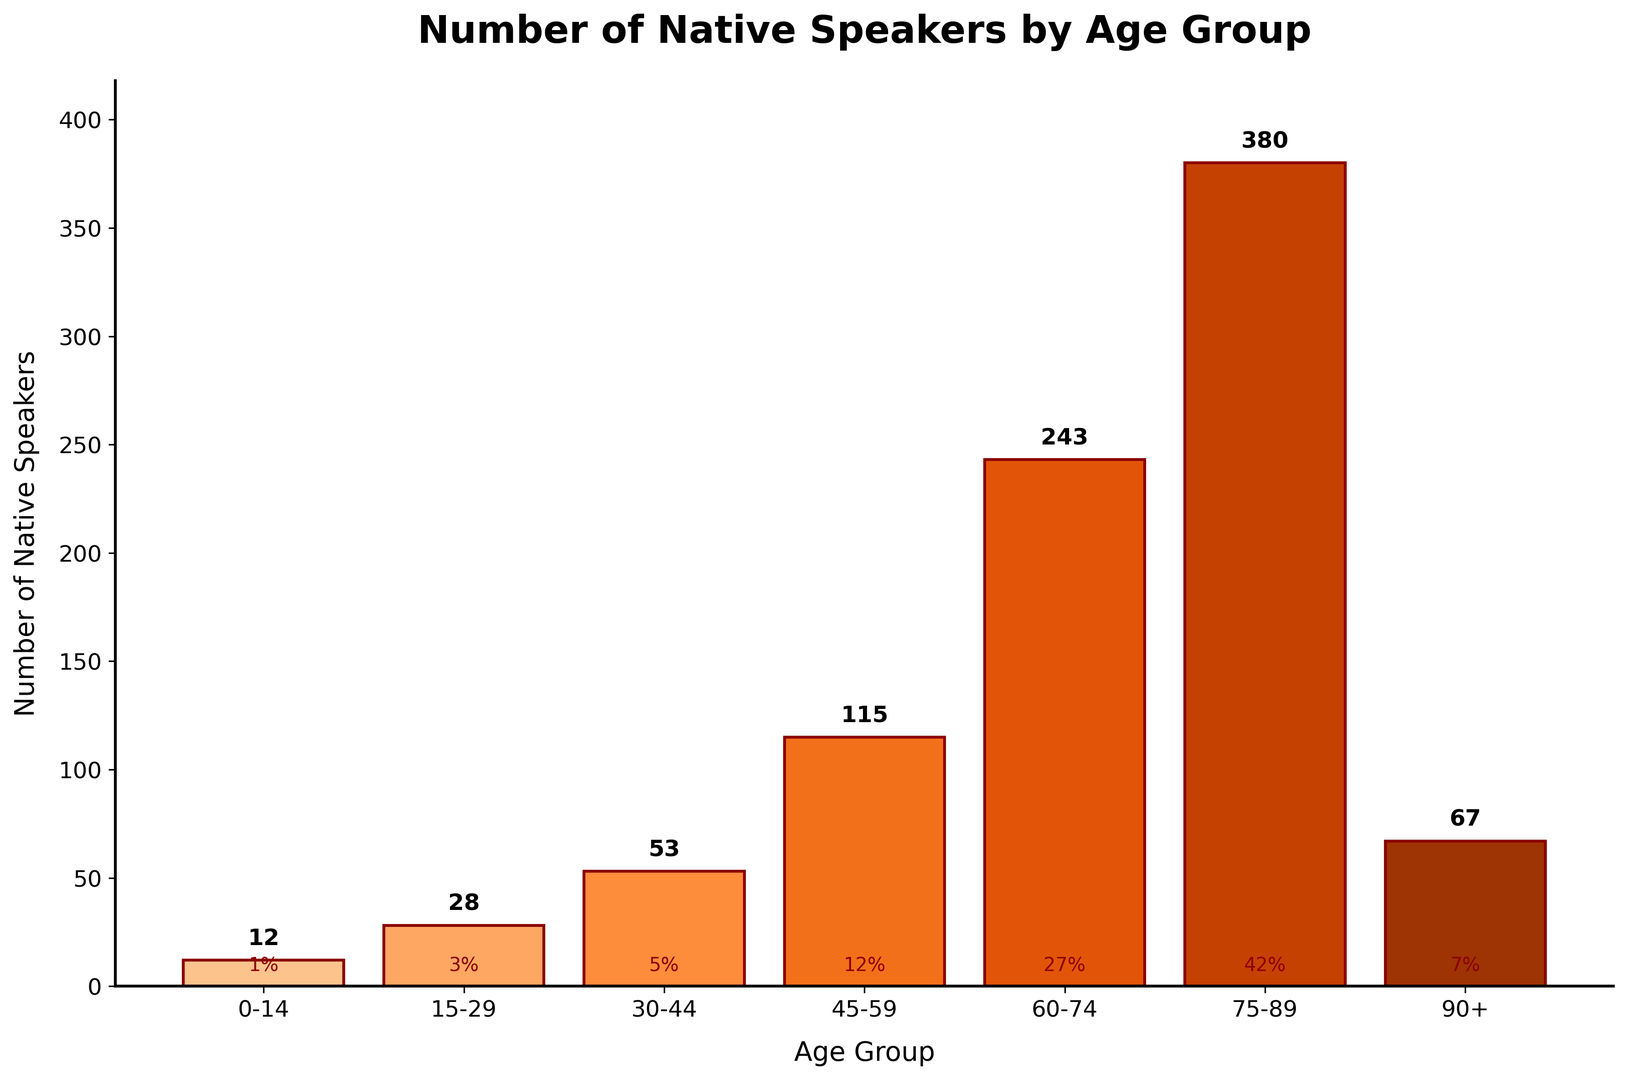What age group has the highest number of native speakers? From the figure, the bar representing the age group 75-89 is the tallest, indicating that it has the highest number of native speakers.
Answer: 75-89 Which age group has the lowest number of native speakers? The shortest bar in the figure corresponds to the age group 0-14, indicating that it has the lowest number of native speakers.
Answer: 0-14 What's the difference in the number of native speakers between the age groups 45-59 and 90+? The number of native speakers in the age group 45-59 is 115 while for the age group 90+ it is 67. The difference is 115 - 67 = 48.
Answer: 48 What is the combined number of native speakers in the age groups 15-29 and 30-44? The number of native speakers in the age group 15-29 is 28 and in the age group 30-44 is 53. The combined number is 28 + 53 = 81.
Answer: 81 What percentage of the total number of native speakers does the age group 30-44 represent? The total number of native speakers is 12 + 28 + 53 + 115 + 243 + 380 + 67 = 898. The number of speakers in the age group 30-44 is 53. The percentage is (53 / 898) * 100 ≈ 5.9%.
Answer: 5.9% How many native speakers are there in the age groups above 60 years old? The number of native speakers in the age group 60-74 is 243, in the age group 75-89 is 380, and in the age group 90+ is 67. The total number is 243 + 380 + 67 = 690.
Answer: 690 What is the average number of native speakers in the age groups below 45 years old? The age groups below 45 years old are 0-14, 15-29, and 30-44 with 12, 28, and 53 native speakers respectively. The total number is 12 + 28 + 53 = 93. There are 3 age groups, so the average is 93 / 3 = 31.
Answer: 31 Are there more native speakers in the 60-74 age group or the 0-44 age group combined? The 60-74 age group has 243 native speakers. The combined number for the 0-44 age group is 12 + 28 + 53 = 93. 243 is greater than 93.
Answer: 60-74 Which age group represents close to a quarter (25%) of the total native speakers? The total number of native speakers is 898. A quarter of the total is 898 * 0.25 = 224.5. The age group 60-74 has 243 native speakers, which is closest to 224.5.
Answer: 60-74 